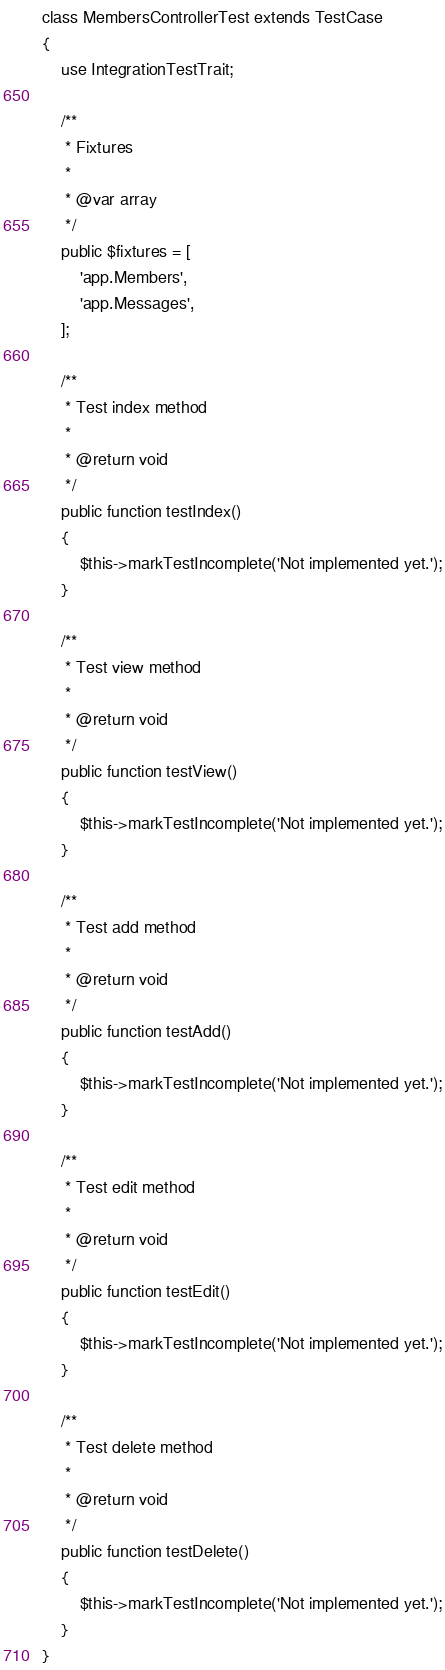<code> <loc_0><loc_0><loc_500><loc_500><_PHP_>class MembersControllerTest extends TestCase
{
    use IntegrationTestTrait;

    /**
     * Fixtures
     *
     * @var array
     */
    public $fixtures = [
        'app.Members',
        'app.Messages',
    ];

    /**
     * Test index method
     *
     * @return void
     */
    public function testIndex()
    {
        $this->markTestIncomplete('Not implemented yet.');
    }

    /**
     * Test view method
     *
     * @return void
     */
    public function testView()
    {
        $this->markTestIncomplete('Not implemented yet.');
    }

    /**
     * Test add method
     *
     * @return void
     */
    public function testAdd()
    {
        $this->markTestIncomplete('Not implemented yet.');
    }

    /**
     * Test edit method
     *
     * @return void
     */
    public function testEdit()
    {
        $this->markTestIncomplete('Not implemented yet.');
    }

    /**
     * Test delete method
     *
     * @return void
     */
    public function testDelete()
    {
        $this->markTestIncomplete('Not implemented yet.');
    }
}
</code> 